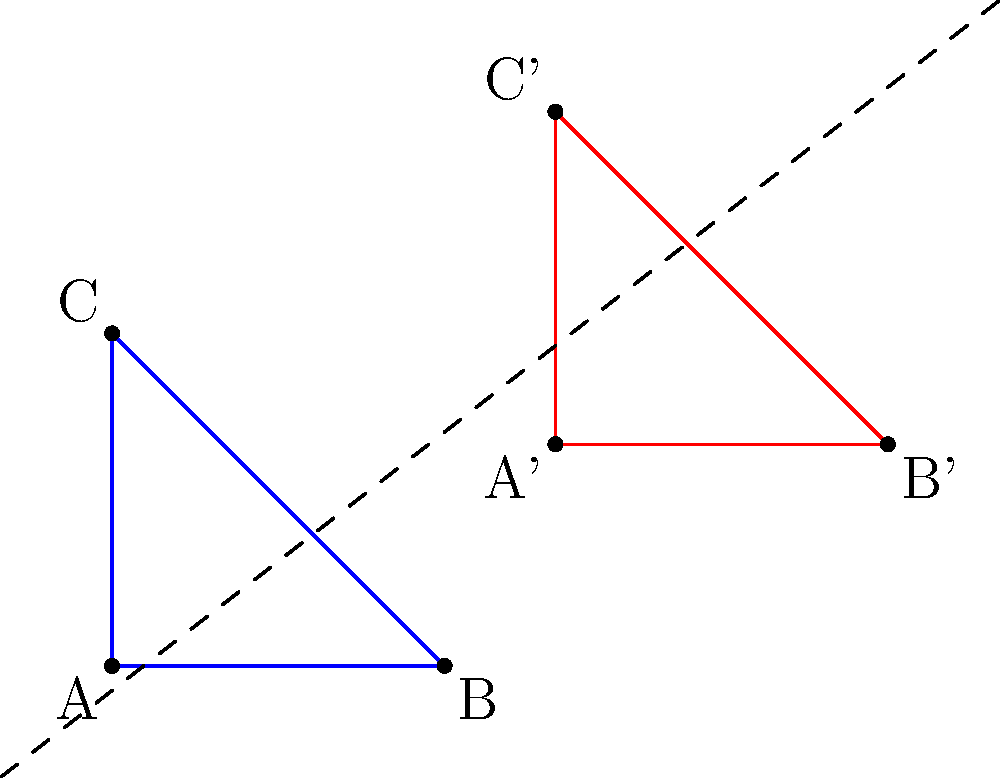As an editor overseeing a veteran author's work on transformational geometry, you come across a figure in their manuscript. The blue triangle ABC has been transformed to the red triangle A'B'C'. Identify and describe the sequence of transformations that maps triangle ABC onto triangle A'B'C'. To determine the sequence of transformations, let's analyze the changes step-by-step:

1. First, observe that the triangles are congruent, maintaining their shape and size. This suggests that only rigid transformations (translation, rotation, and reflection) are involved.

2. Notice that the orientation of the triangles is the same (both are oriented counterclockwise). This eliminates reflection as a possibility.

3. The dashed line in the figure suggests a line of symmetry, which is often used to indicate a glide reflection.

4. A glide reflection is a composition of a reflection and a translation parallel to the line of reflection.

5. To map ABC onto A'B'C':
   a) Reflect triangle ABC over the dashed line. This would place it in a position parallel to A'B'C' but not coincident with it.
   b) Translate the reflected triangle parallel to the dashed line until it coincides with A'B'C'.

6. We can verify this by checking that corresponding points (A and A', B and B', C and C') are equidistant from the dashed line and that the line segments connecting them are parallel to the dashed line.

Therefore, the transformation is a glide reflection, which is a single reflection followed by a translation parallel to the line of reflection.
Answer: Glide reflection 